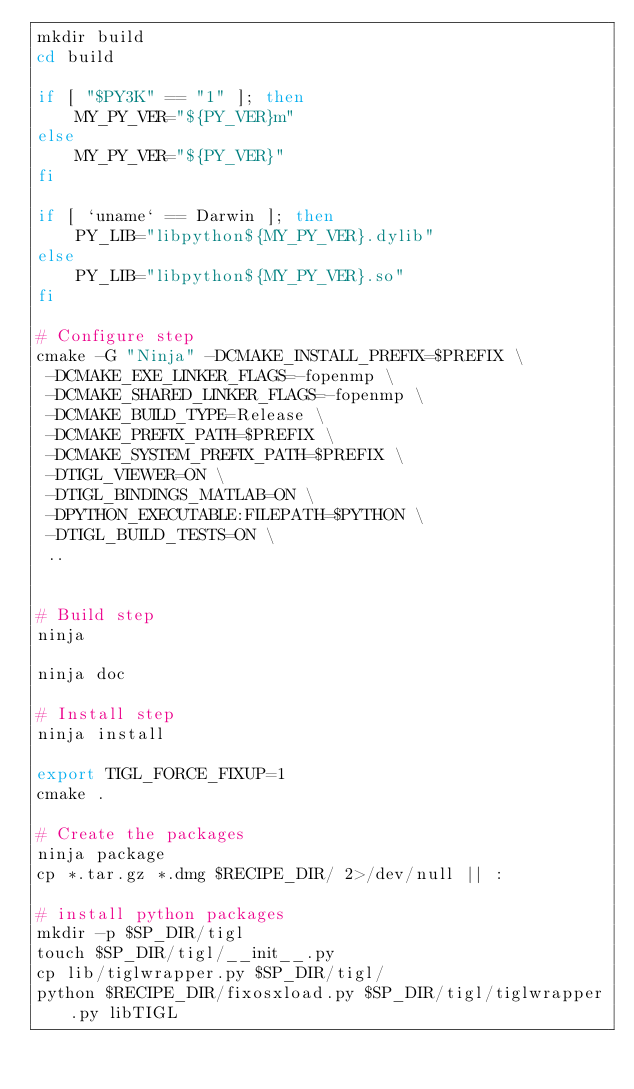<code> <loc_0><loc_0><loc_500><loc_500><_Bash_>mkdir build
cd build

if [ "$PY3K" == "1" ]; then
    MY_PY_VER="${PY_VER}m"
else
    MY_PY_VER="${PY_VER}"
fi

if [ `uname` == Darwin ]; then
    PY_LIB="libpython${MY_PY_VER}.dylib"
else
    PY_LIB="libpython${MY_PY_VER}.so"
fi

# Configure step
cmake -G "Ninja" -DCMAKE_INSTALL_PREFIX=$PREFIX \
 -DCMAKE_EXE_LINKER_FLAGS=-fopenmp \
 -DCMAKE_SHARED_LINKER_FLAGS=-fopenmp \
 -DCMAKE_BUILD_TYPE=Release \
 -DCMAKE_PREFIX_PATH=$PREFIX \
 -DCMAKE_SYSTEM_PREFIX_PATH=$PREFIX \
 -DTIGL_VIEWER=ON \
 -DTIGL_BINDINGS_MATLAB=ON \
 -DPYTHON_EXECUTABLE:FILEPATH=$PYTHON \
 -DTIGL_BUILD_TESTS=ON \
 ..


# Build step
ninja

ninja doc

# Install step
ninja install

export TIGL_FORCE_FIXUP=1
cmake .

# Create the packages
ninja package
cp *.tar.gz *.dmg $RECIPE_DIR/ 2>/dev/null || :

# install python packages
mkdir -p $SP_DIR/tigl
touch $SP_DIR/tigl/__init__.py
cp lib/tiglwrapper.py $SP_DIR/tigl/
python $RECIPE_DIR/fixosxload.py $SP_DIR/tigl/tiglwrapper.py libTIGL
</code> 